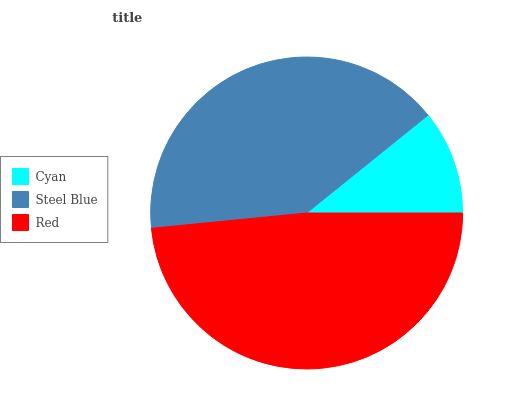Is Cyan the minimum?
Answer yes or no. Yes. Is Red the maximum?
Answer yes or no. Yes. Is Steel Blue the minimum?
Answer yes or no. No. Is Steel Blue the maximum?
Answer yes or no. No. Is Steel Blue greater than Cyan?
Answer yes or no. Yes. Is Cyan less than Steel Blue?
Answer yes or no. Yes. Is Cyan greater than Steel Blue?
Answer yes or no. No. Is Steel Blue less than Cyan?
Answer yes or no. No. Is Steel Blue the high median?
Answer yes or no. Yes. Is Steel Blue the low median?
Answer yes or no. Yes. Is Red the high median?
Answer yes or no. No. Is Cyan the low median?
Answer yes or no. No. 